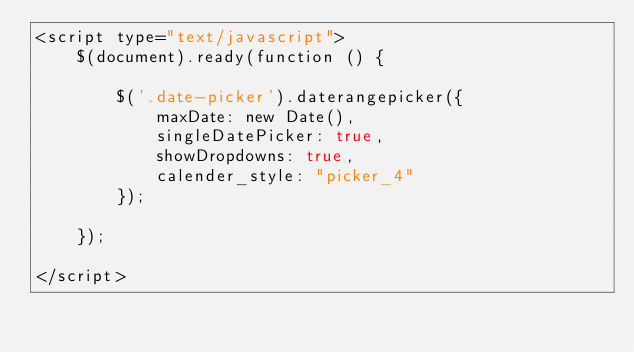<code> <loc_0><loc_0><loc_500><loc_500><_PHP_><script type="text/javascript">
    $(document).ready(function () {

        $('.date-picker').daterangepicker({
            maxDate: new Date(),
            singleDatePicker: true,
            showDropdowns: true,
            calender_style: "picker_4"
        });

    });

</script>
</code> 